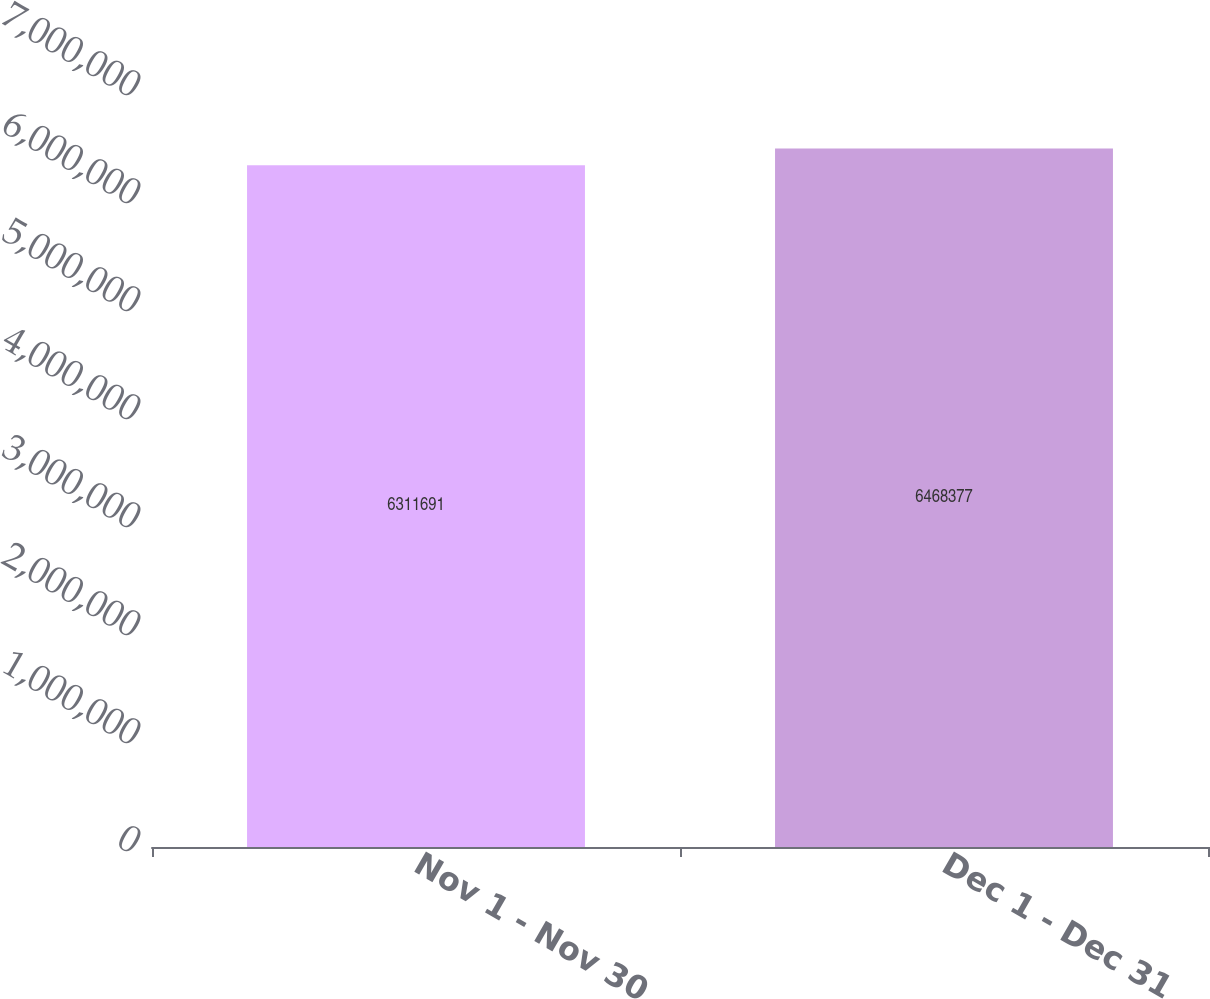Convert chart. <chart><loc_0><loc_0><loc_500><loc_500><bar_chart><fcel>Nov 1 - Nov 30<fcel>Dec 1 - Dec 31<nl><fcel>6.31169e+06<fcel>6.46838e+06<nl></chart> 